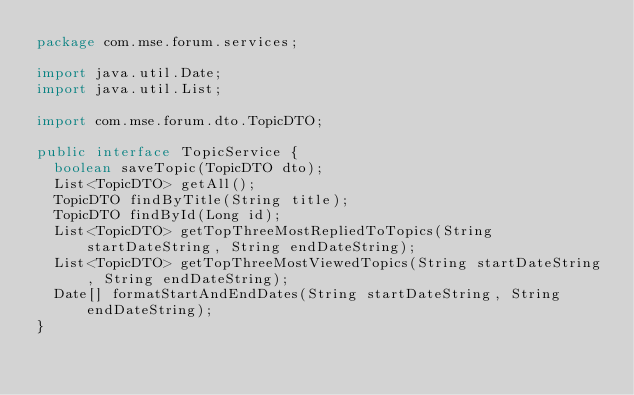Convert code to text. <code><loc_0><loc_0><loc_500><loc_500><_Java_>package com.mse.forum.services;

import java.util.Date;
import java.util.List;

import com.mse.forum.dto.TopicDTO;

public interface TopicService {
	boolean saveTopic(TopicDTO dto);
	List<TopicDTO> getAll();
	TopicDTO findByTitle(String title);
	TopicDTO findById(Long id);
	List<TopicDTO> getTopThreeMostRepliedToTopics(String startDateString, String endDateString);
	List<TopicDTO> getTopThreeMostViewedTopics(String startDateString, String endDateString);
	Date[] formatStartAndEndDates(String startDateString, String endDateString);
}</code> 